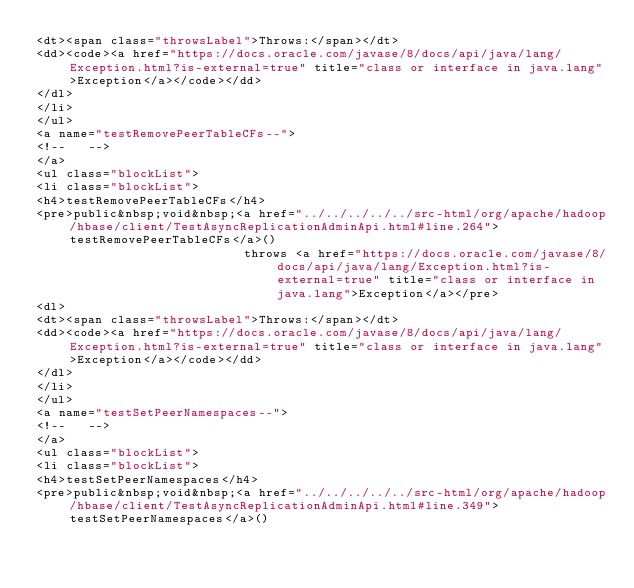<code> <loc_0><loc_0><loc_500><loc_500><_HTML_><dt><span class="throwsLabel">Throws:</span></dt>
<dd><code><a href="https://docs.oracle.com/javase/8/docs/api/java/lang/Exception.html?is-external=true" title="class or interface in java.lang">Exception</a></code></dd>
</dl>
</li>
</ul>
<a name="testRemovePeerTableCFs--">
<!--   -->
</a>
<ul class="blockList">
<li class="blockList">
<h4>testRemovePeerTableCFs</h4>
<pre>public&nbsp;void&nbsp;<a href="../../../../../src-html/org/apache/hadoop/hbase/client/TestAsyncReplicationAdminApi.html#line.264">testRemovePeerTableCFs</a>()
                            throws <a href="https://docs.oracle.com/javase/8/docs/api/java/lang/Exception.html?is-external=true" title="class or interface in java.lang">Exception</a></pre>
<dl>
<dt><span class="throwsLabel">Throws:</span></dt>
<dd><code><a href="https://docs.oracle.com/javase/8/docs/api/java/lang/Exception.html?is-external=true" title="class or interface in java.lang">Exception</a></code></dd>
</dl>
</li>
</ul>
<a name="testSetPeerNamespaces--">
<!--   -->
</a>
<ul class="blockList">
<li class="blockList">
<h4>testSetPeerNamespaces</h4>
<pre>public&nbsp;void&nbsp;<a href="../../../../../src-html/org/apache/hadoop/hbase/client/TestAsyncReplicationAdminApi.html#line.349">testSetPeerNamespaces</a>()</code> 